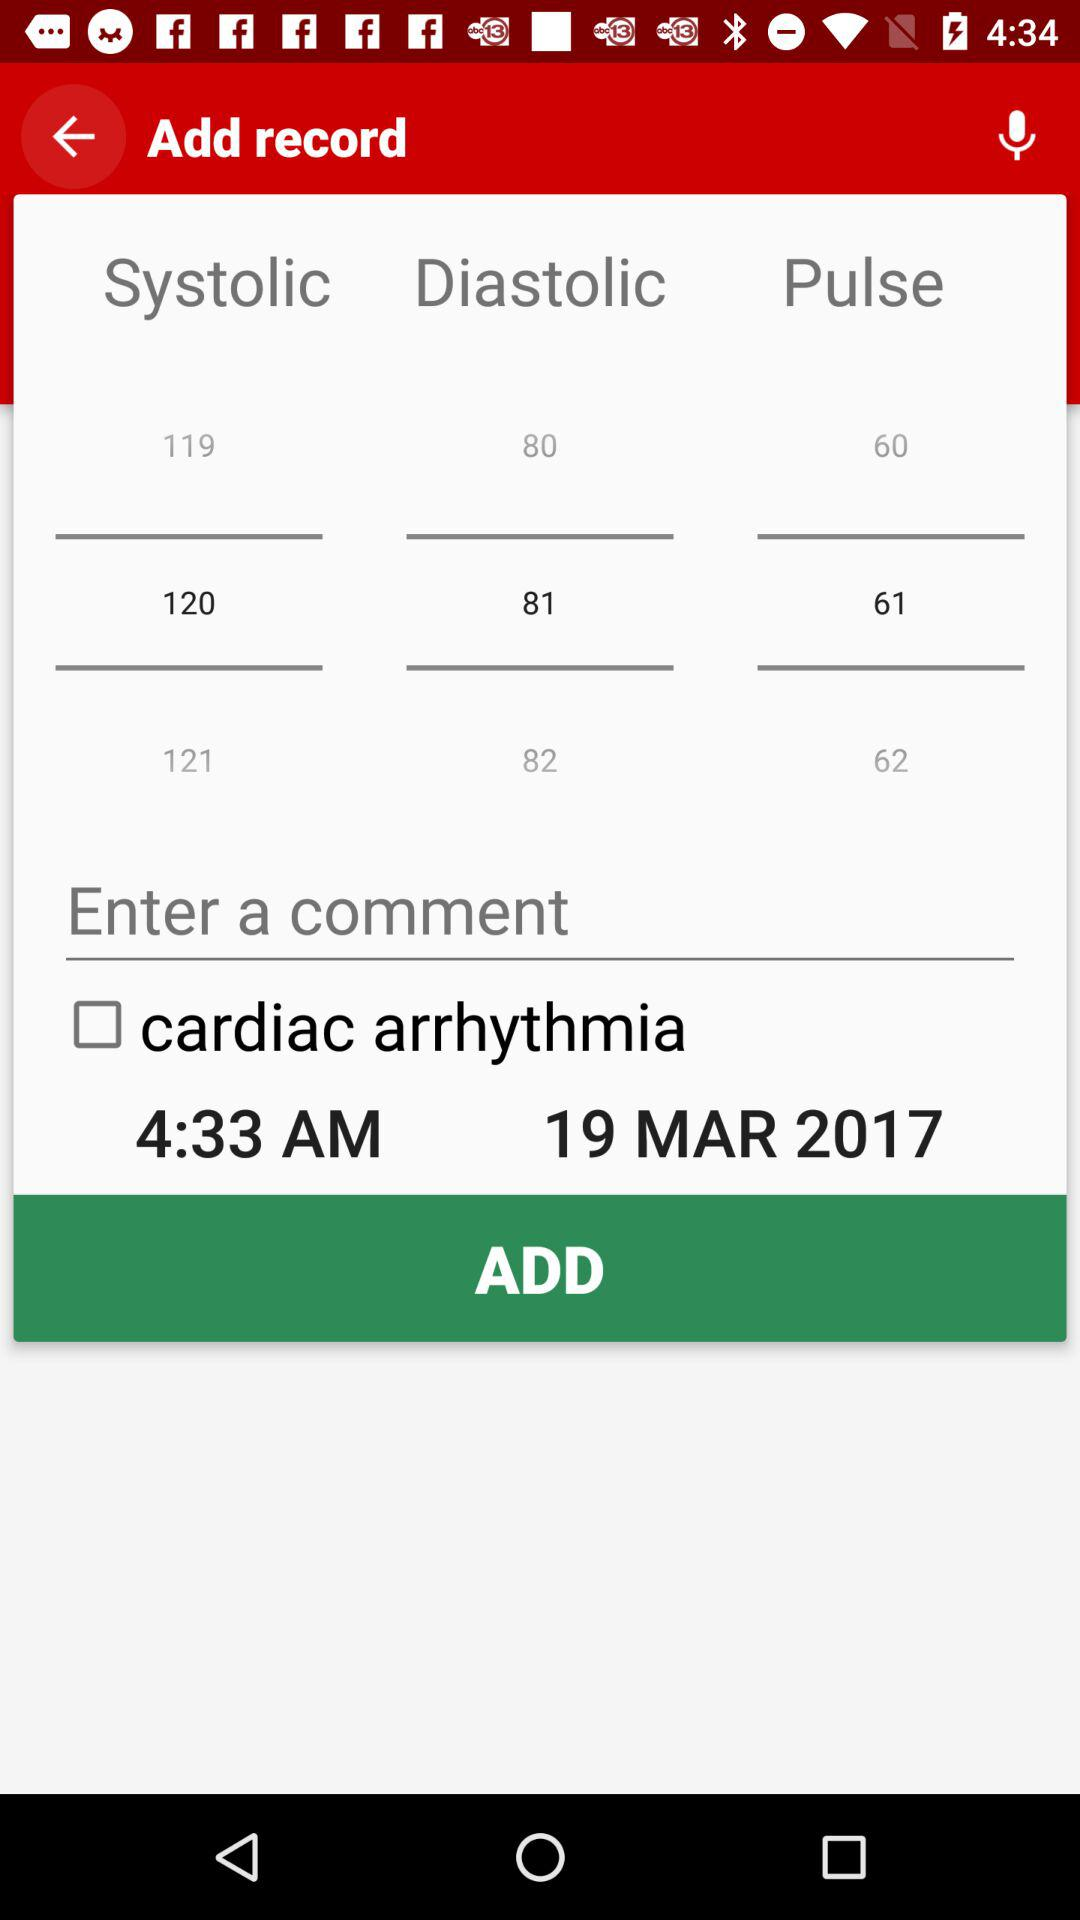What time record can be added? The record of 4:33 a.m. can be added. 